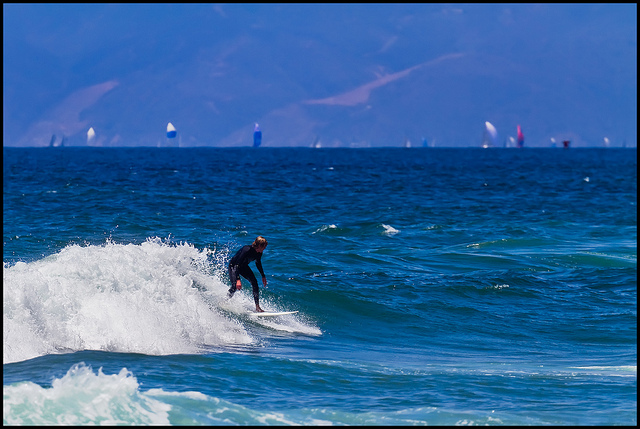<image>What are the white things in the sky? I am not sure what the white things in the sky are. It could be clouds, sails or even mountain trails. What are the white things in the sky? I am not sure what the white things in the sky are. It can be seen as clouds or sails. 